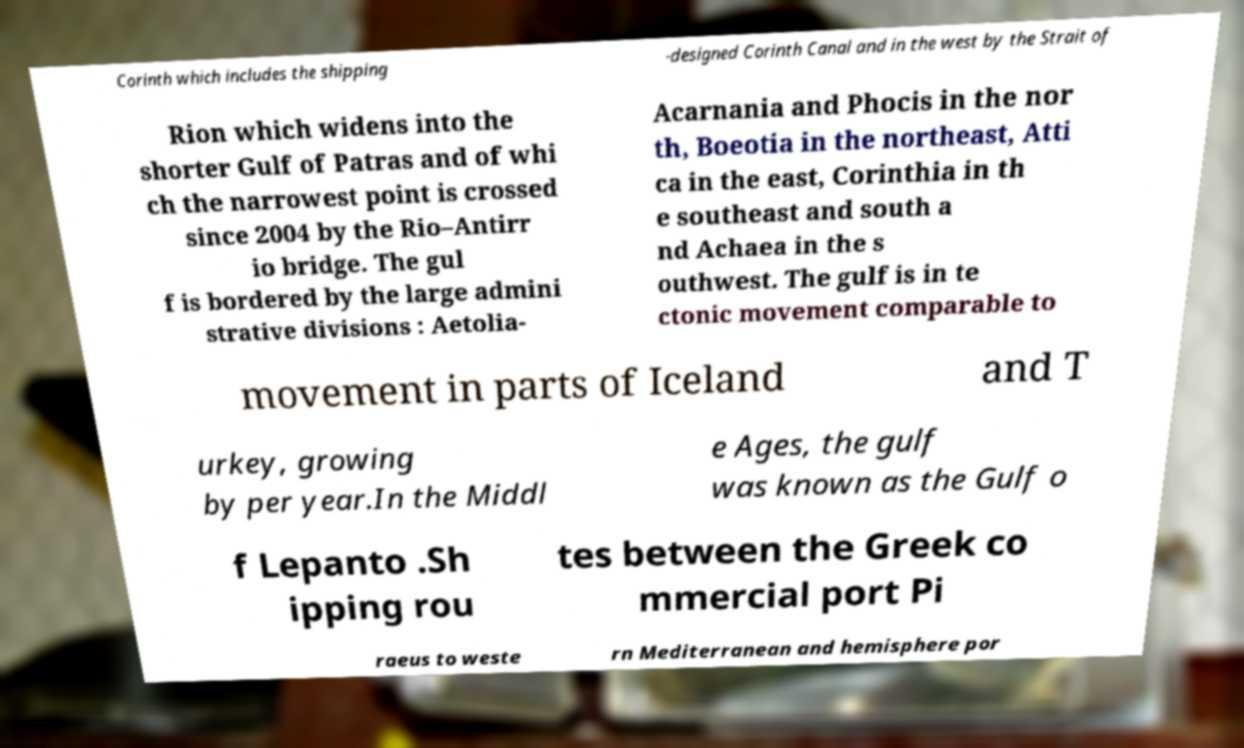For documentation purposes, I need the text within this image transcribed. Could you provide that? Corinth which includes the shipping -designed Corinth Canal and in the west by the Strait of Rion which widens into the shorter Gulf of Patras and of whi ch the narrowest point is crossed since 2004 by the Rio–Antirr io bridge. The gul f is bordered by the large admini strative divisions : Aetolia- Acarnania and Phocis in the nor th, Boeotia in the northeast, Atti ca in the east, Corinthia in th e southeast and south a nd Achaea in the s outhwest. The gulf is in te ctonic movement comparable to movement in parts of Iceland and T urkey, growing by per year.In the Middl e Ages, the gulf was known as the Gulf o f Lepanto .Sh ipping rou tes between the Greek co mmercial port Pi raeus to weste rn Mediterranean and hemisphere por 